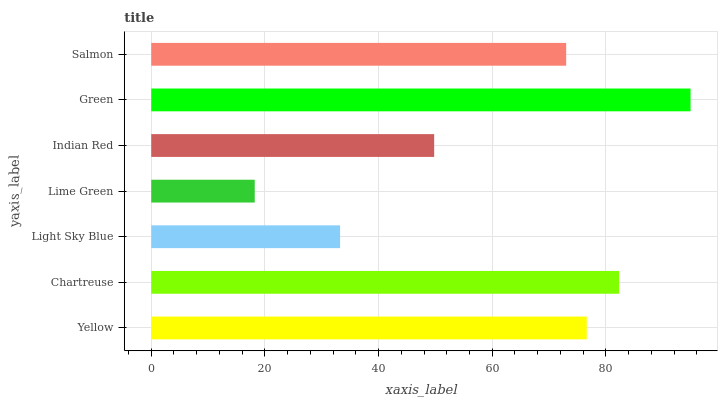Is Lime Green the minimum?
Answer yes or no. Yes. Is Green the maximum?
Answer yes or no. Yes. Is Chartreuse the minimum?
Answer yes or no. No. Is Chartreuse the maximum?
Answer yes or no. No. Is Chartreuse greater than Yellow?
Answer yes or no. Yes. Is Yellow less than Chartreuse?
Answer yes or no. Yes. Is Yellow greater than Chartreuse?
Answer yes or no. No. Is Chartreuse less than Yellow?
Answer yes or no. No. Is Salmon the high median?
Answer yes or no. Yes. Is Salmon the low median?
Answer yes or no. Yes. Is Indian Red the high median?
Answer yes or no. No. Is Yellow the low median?
Answer yes or no. No. 